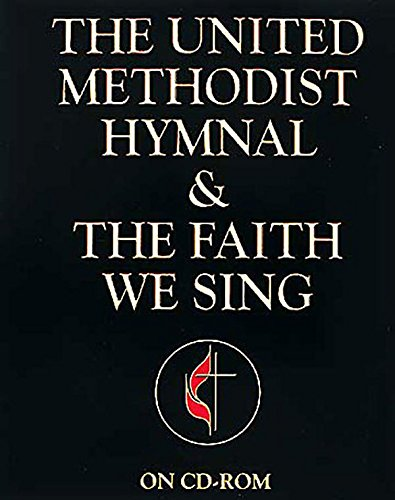What is the title of this book? The book in the image is titled 'The United Methodist Hymnal & The Faith We Sing.' This volume likely features a collection of hymns and spiritual songs for use in worship services. 